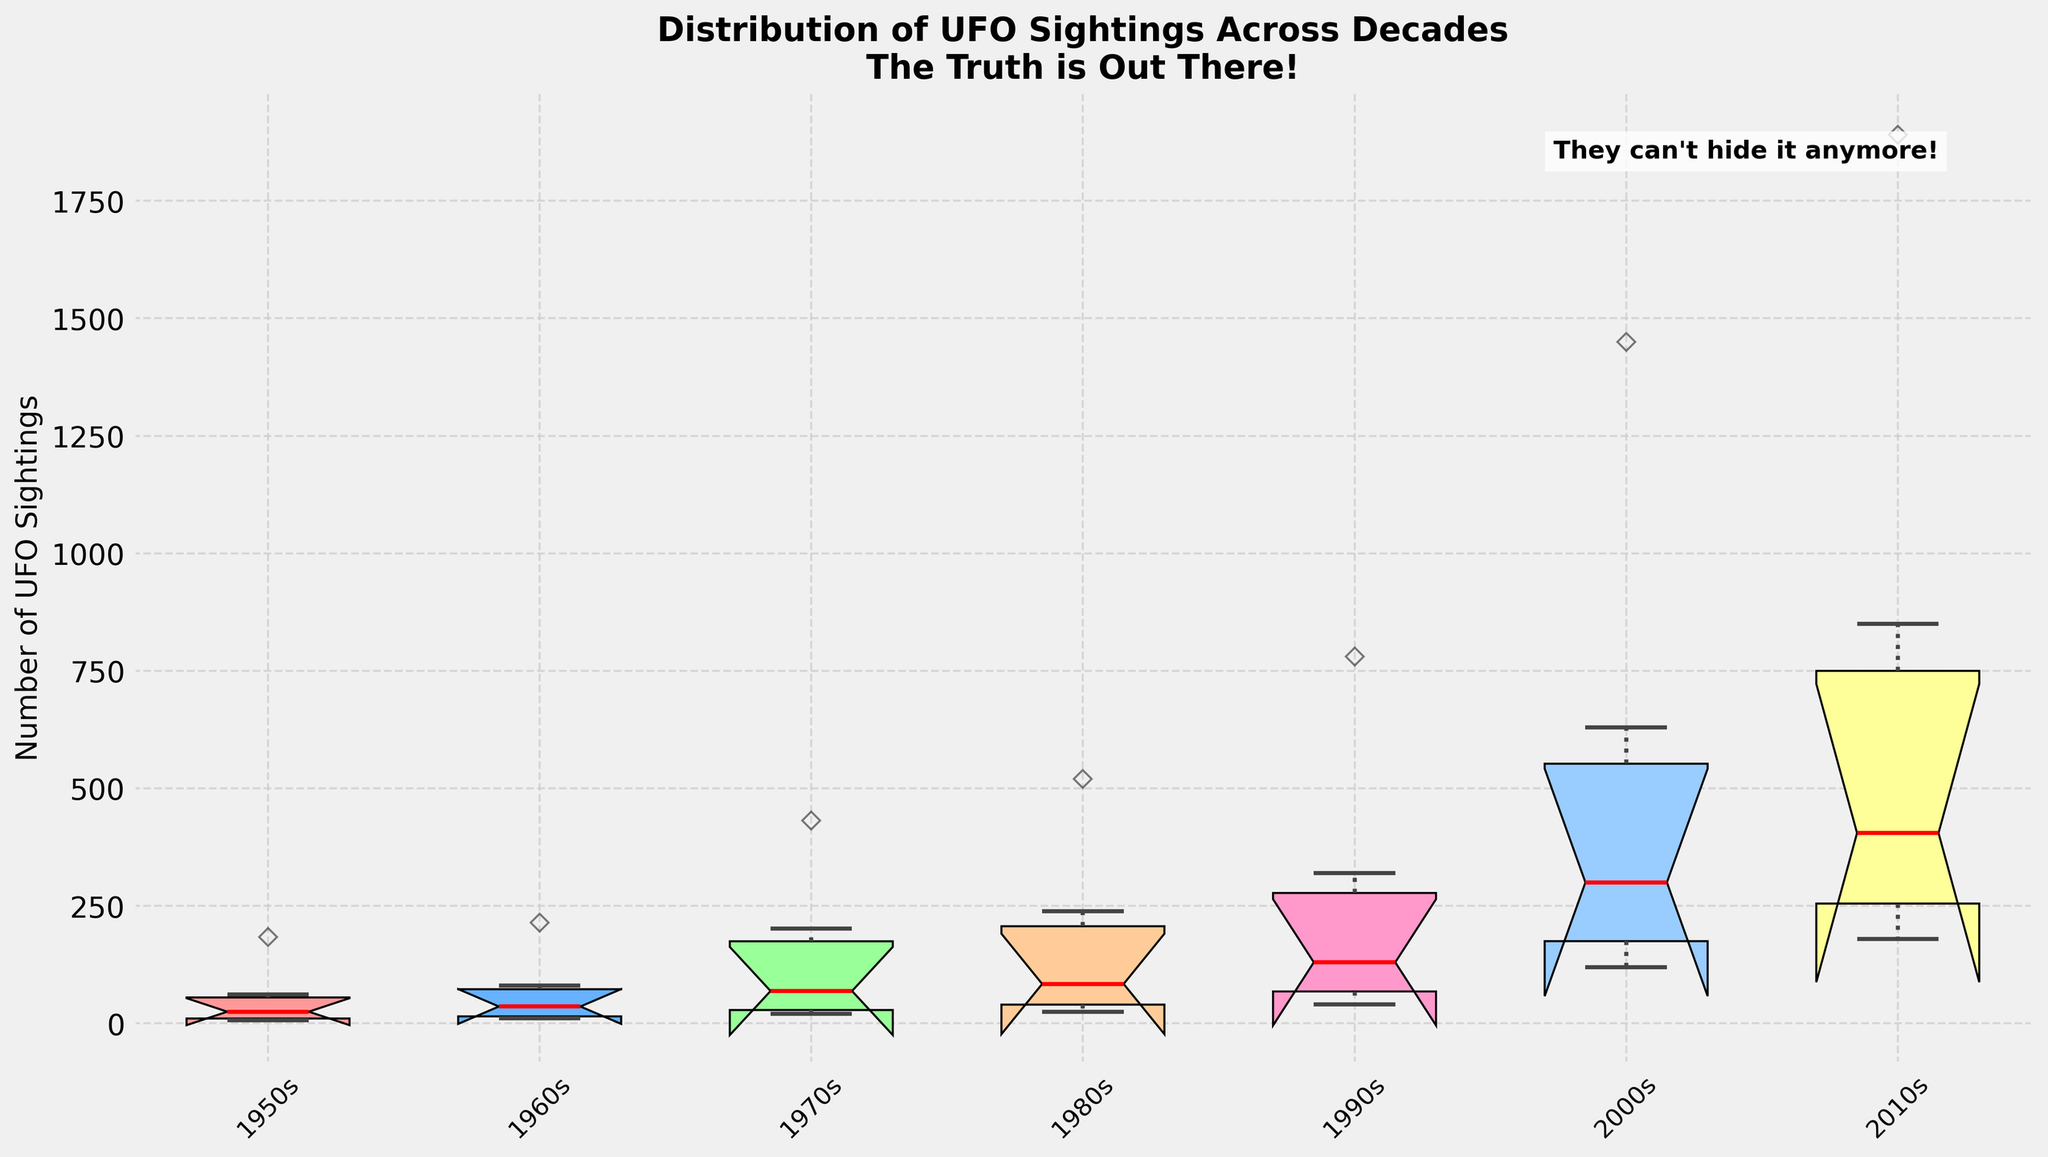What's the title of the chart? Look at the top of the chart where the title is usually placed. The title informs you about the subject of the chart.
Answer: Distribution of UFO Sightings Across Decades Which decade has the highest number of UFO sightings? Identify the decade with the highest median or highest range of UFO sightings by observing the position of the notches and the length of the box plots.
Answer: 2010s How is the y-axis labeled, and what does it represent? Check the label alongside the y-axis. The label provides a description of what the numerical values represent.
Answer: Number of UFO Sightings Which decade has the widest range of UFO sightings? Observe the length of the box plots which indicates the interquartile range. The decade with the widest box has the largest range.
Answer: 2010s What do the red lines inside each box represent? The red lines inside the boxes represent the statistical median of the datasets.
Answer: Median Are there any annotations on the chart, and what do they say? Annotations are additional notes usually placed within or around the chart to provide contextual information. Check the top-right corner within the chart.
Answer: They can't hide it anymore! Which decade shows the smallest variability in UFO sightings? Look for the box plot with the shortest whiskers and narrowest interquartile range.
Answer: 1950s What is the trend in median UFO sightings over the decades? Observe the red lines inside the boxes to see if they generally move upward, downward, or stay the same over the decades from left to right.
Answer: Increasing How do the UFO sightings in the 1980s and 1990s compare in terms of IQR (Interquartile Range)? Compare the heights of the boxes (without whiskers) for the 1980s and 1990s to see which one is taller.
Answer: 1990s have a larger IQR What is the color pattern for the box plots, and how does it help interpret the data? Note the colors used for each decade group and how they help differentiate between decades. Mention the progression or pattern if any.
Answer: Each decade has a unique color, making it easy to distinguish between them 